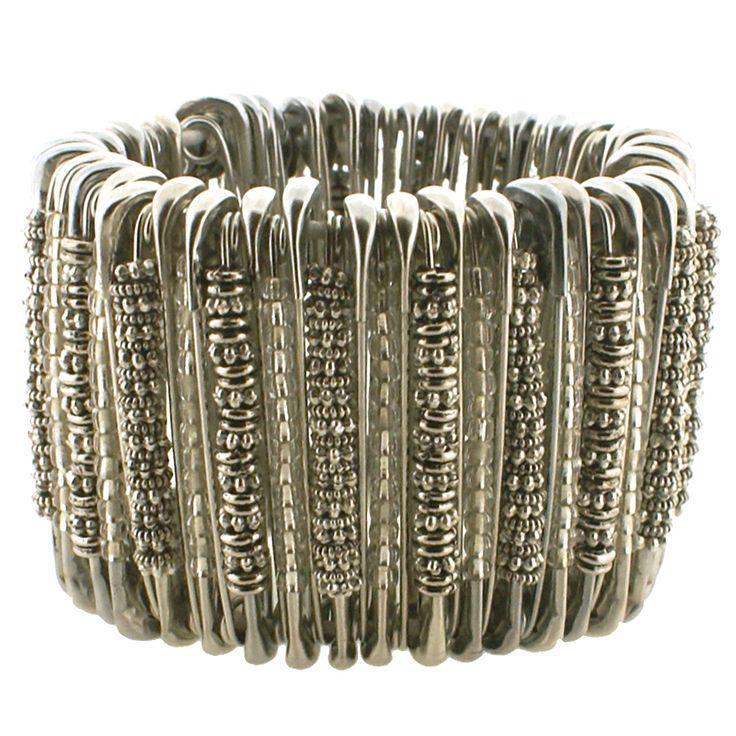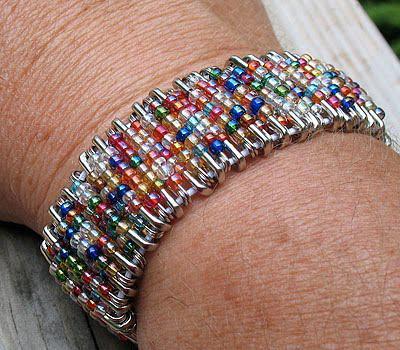The first image is the image on the left, the second image is the image on the right. Assess this claim about the two images: "One of the bracelets features small, round, rainbow colored beads including the colors pink and orange.". Correct or not? Answer yes or no. Yes. The first image is the image on the left, the second image is the image on the right. Analyze the images presented: Is the assertion "jewelry made from bobby pins are on human wrists" valid? Answer yes or no. Yes. 